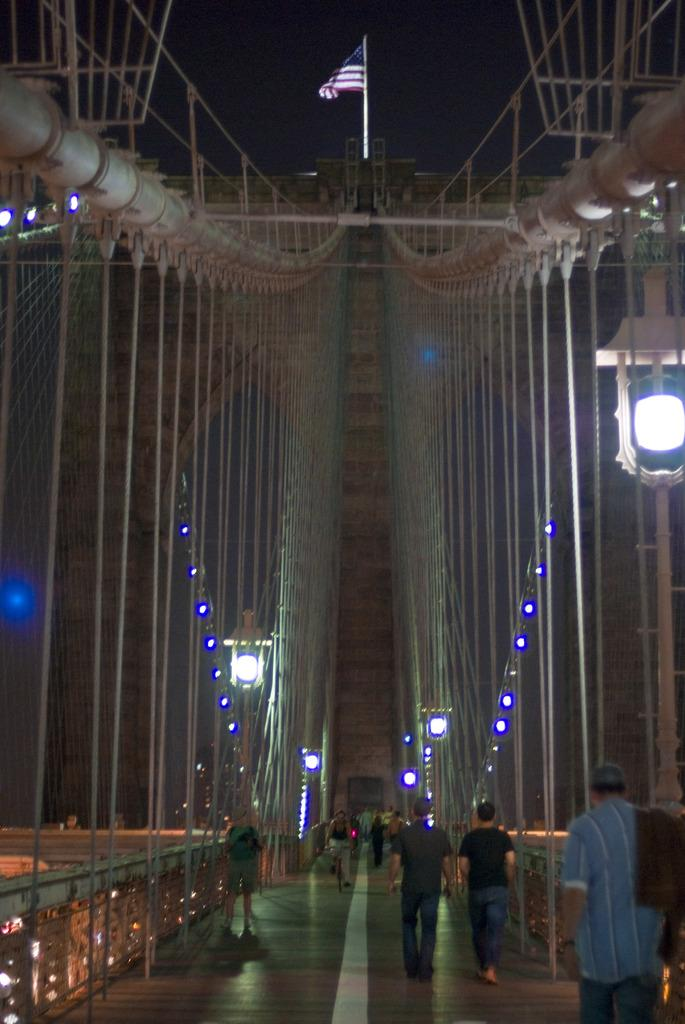What structure is present in the image? There is a bridge in the image. What are people doing on the bridge? People are walking on the bridge. Can you describe the bridge's construction? The construction of the bridge is visible in the image. What else can be seen in the image besides the bridge? There are lights in the image. Where is the flag located in the image? There is a flag at the top of the image. What type of juice is being served in the lunchroom in the image? There is no lunchroom or juice present in the image; it features a bridge with people walking on it, lights, and a flag. How many birds are in the flock flying over the bridge in the image? There are no birds or flock visible in the image; it only shows a bridge with people walking on it, lights, and a flag. 